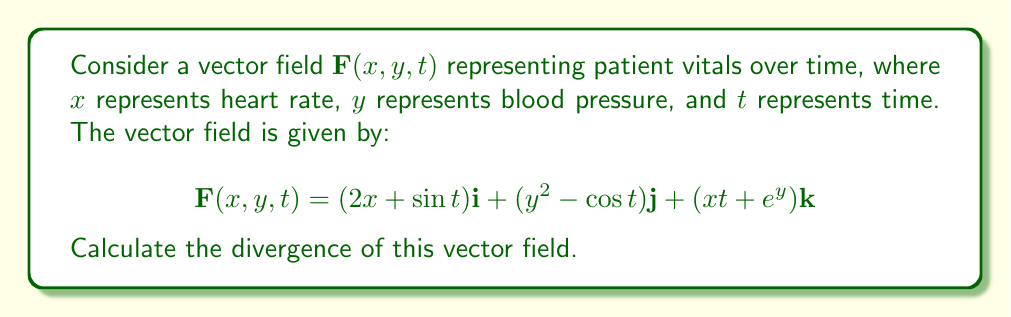Provide a solution to this math problem. To calculate the divergence of the vector field, we need to follow these steps:

1) The divergence of a vector field $\mathbf{F}(x, y, z) = P\mathbf{i} + Q\mathbf{j} + R\mathbf{k}$ is given by:

   $$\nabla \cdot \mathbf{F} = \frac{\partial P}{\partial x} + \frac{\partial Q}{\partial y} + \frac{\partial R}{\partial z}$$

2) In our case, we have:
   $P = 2x + \sin t$
   $Q = y^2 - \cos t$
   $R = xt + e^y$

3) Now, let's calculate each partial derivative:

   $\frac{\partial P}{\partial x} = \frac{\partial}{\partial x}(2x + \sin t) = 2$

   $\frac{\partial Q}{\partial y} = \frac{\partial}{\partial y}(y^2 - \cos t) = 2y$

   $\frac{\partial R}{\partial t} = \frac{\partial}{\partial t}(xt + e^y) = x$

4) Now, we sum these partial derivatives:

   $$\nabla \cdot \mathbf{F} = \frac{\partial P}{\partial x} + \frac{\partial Q}{\partial y} + \frac{\partial R}{\partial t}$$
   $$\nabla \cdot \mathbf{F} = 2 + 2y + x$$

This is the divergence of the given vector field.
Answer: $2 + 2y + x$ 